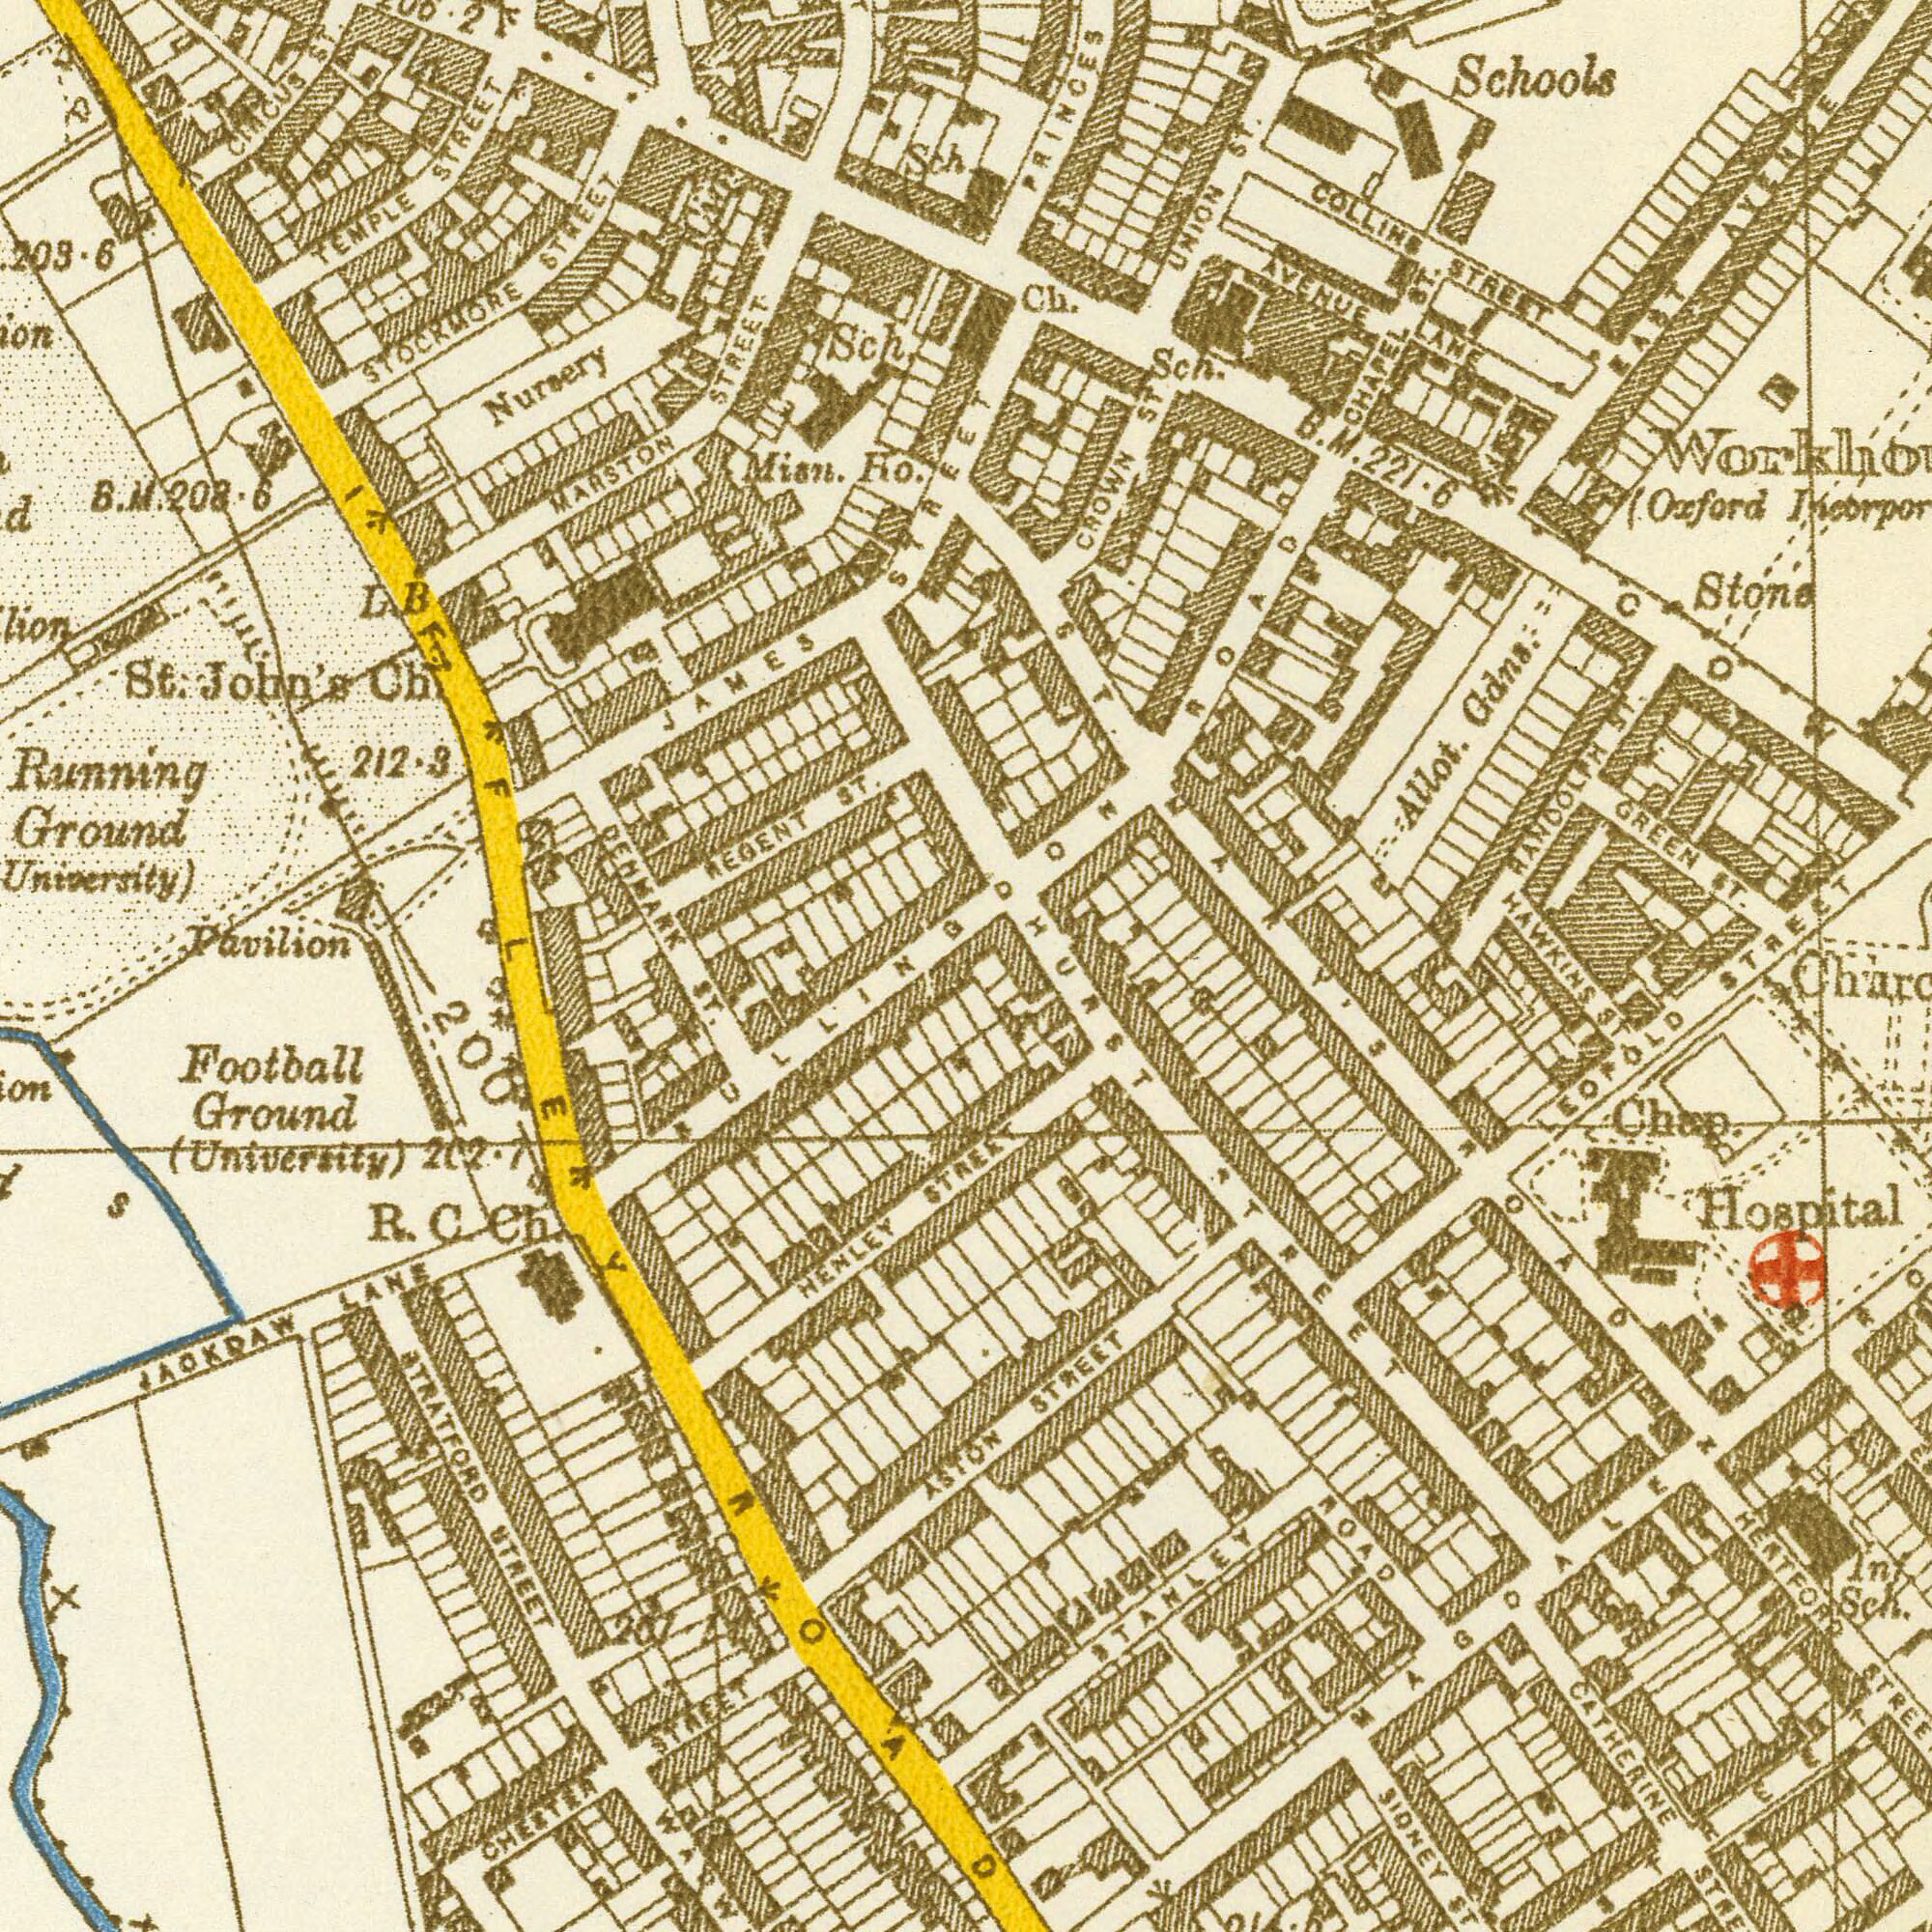What text can you see in the top-right section? Schools PRINCES Allot. Gdns. Stone Sch. (Oxford COLLINS STREET GREEN ST. Ch. CROWN ST UNION St. RANDOLPH ST. AVENUE LANE STREET HAWKINS B. M. 221.6 CHAPEL ST. EAST AVENUE ST. MARY'S ROAD COWLEY What text can you see in the top-left section? Running Ground (University) Mian. Ho. JAMES STREET Pavilion Sch TEMPLE STREET Nursery St. John's Ch REGENT ST. STOCKMORE STREET MARSTON STREET Sch DENMARK CIRCUS ST. D. B BULLINGDON IFFLEY 203.6 B. M. 208.6 212.3 What text is visible in the lower-right corner? CATHERINE STREET SIDNEY ST Hospital HERTFORD STREET Church Chap. STANLEY ROAD Int. Sch. STREET LEOPOLD ST. ROAD HURST STREET STREET MAGDALEN STREET What text appears in the bottom-left area of the image? ST. STRATFORD STREET Football Ground (UnIversity) JACKDAW LANE R. C. Ch. 200 ASTON HENLEY ROAD 202.7 207.1 